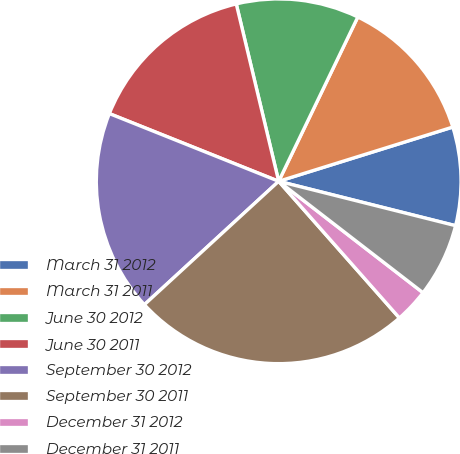<chart> <loc_0><loc_0><loc_500><loc_500><pie_chart><fcel>March 31 2012<fcel>March 31 2011<fcel>June 30 2012<fcel>June 30 2011<fcel>September 30 2012<fcel>September 30 2011<fcel>December 31 2012<fcel>December 31 2011<nl><fcel>8.72%<fcel>13.05%<fcel>10.88%<fcel>15.21%<fcel>17.88%<fcel>24.69%<fcel>3.02%<fcel>6.55%<nl></chart> 